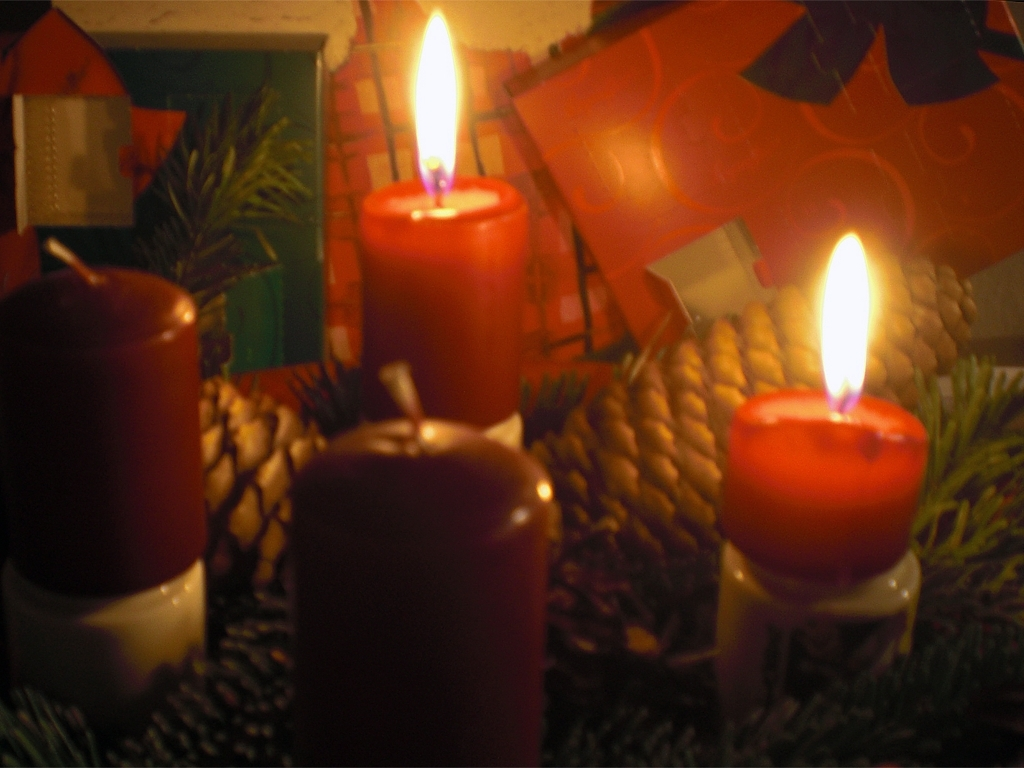Can you describe the setting depicted in this image? The image appears to capture a warm and intimate setting, likely during a festive occasion. Two lit candles with a clear, glowing flame stand in the foreground, illuminating nearby pine cones and branches suggestive of holiday decor. The background, though somewhat obscured, features elements that evoke the spirit of Christmas, including what might be wrapping paper and gift boxes. 